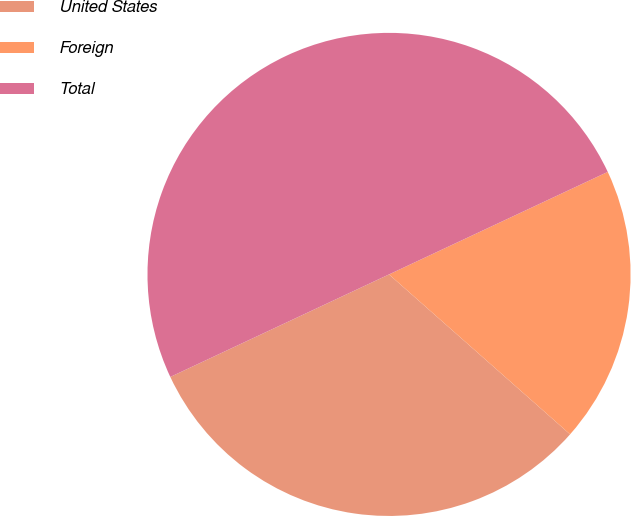Convert chart. <chart><loc_0><loc_0><loc_500><loc_500><pie_chart><fcel>United States<fcel>Foreign<fcel>Total<nl><fcel>31.51%<fcel>18.49%<fcel>50.0%<nl></chart> 